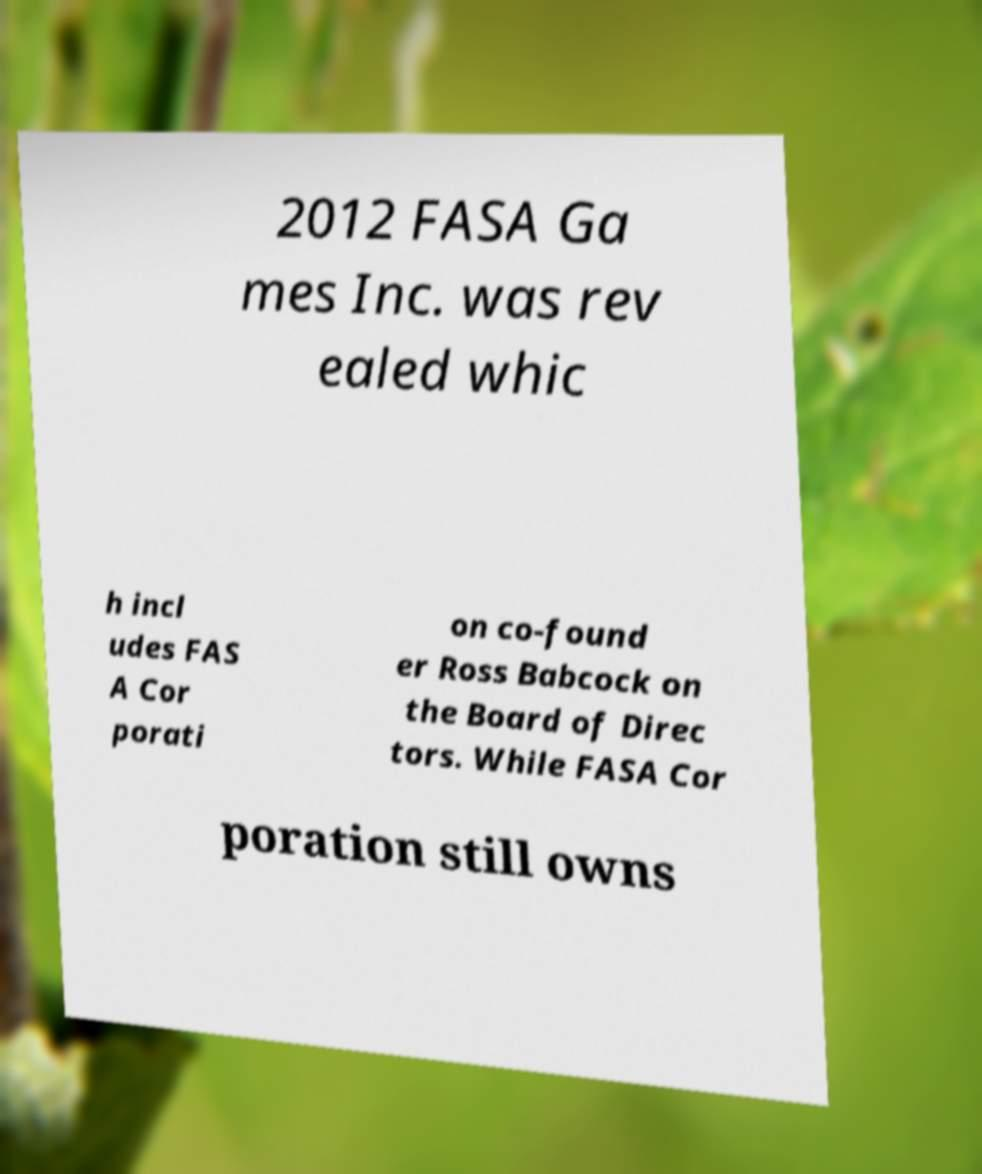Can you read and provide the text displayed in the image?This photo seems to have some interesting text. Can you extract and type it out for me? 2012 FASA Ga mes Inc. was rev ealed whic h incl udes FAS A Cor porati on co-found er Ross Babcock on the Board of Direc tors. While FASA Cor poration still owns 